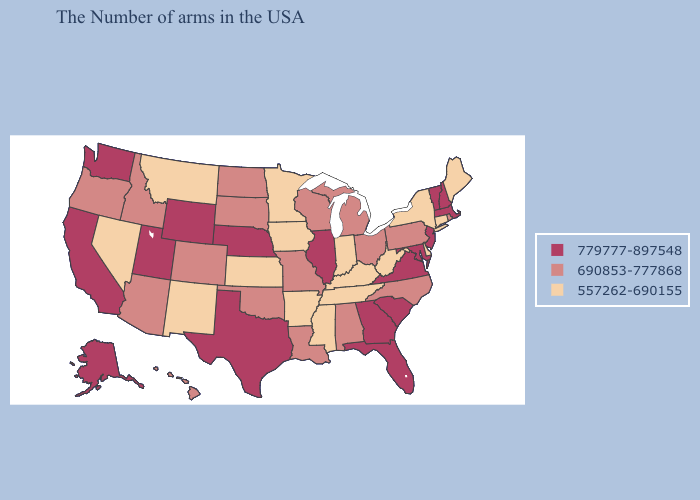What is the value of Minnesota?
Concise answer only. 557262-690155. What is the value of North Dakota?
Short answer required. 690853-777868. Name the states that have a value in the range 779777-897548?
Give a very brief answer. Massachusetts, New Hampshire, Vermont, New Jersey, Maryland, Virginia, South Carolina, Florida, Georgia, Illinois, Nebraska, Texas, Wyoming, Utah, California, Washington, Alaska. Among the states that border New Mexico , which have the highest value?
Be succinct. Texas, Utah. Which states have the lowest value in the USA?
Write a very short answer. Maine, Connecticut, New York, Delaware, West Virginia, Kentucky, Indiana, Tennessee, Mississippi, Arkansas, Minnesota, Iowa, Kansas, New Mexico, Montana, Nevada. Among the states that border Arkansas , which have the lowest value?
Concise answer only. Tennessee, Mississippi. What is the value of Alabama?
Write a very short answer. 690853-777868. What is the lowest value in the USA?
Short answer required. 557262-690155. Name the states that have a value in the range 779777-897548?
Short answer required. Massachusetts, New Hampshire, Vermont, New Jersey, Maryland, Virginia, South Carolina, Florida, Georgia, Illinois, Nebraska, Texas, Wyoming, Utah, California, Washington, Alaska. Which states hav the highest value in the South?
Quick response, please. Maryland, Virginia, South Carolina, Florida, Georgia, Texas. Name the states that have a value in the range 557262-690155?
Answer briefly. Maine, Connecticut, New York, Delaware, West Virginia, Kentucky, Indiana, Tennessee, Mississippi, Arkansas, Minnesota, Iowa, Kansas, New Mexico, Montana, Nevada. Does Texas have the same value as New York?
Short answer required. No. What is the value of Tennessee?
Give a very brief answer. 557262-690155. Which states have the lowest value in the South?
Concise answer only. Delaware, West Virginia, Kentucky, Tennessee, Mississippi, Arkansas. 